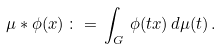<formula> <loc_0><loc_0><loc_500><loc_500>\mu * \phi ( x ) \, \colon = \, \int _ { G } \, \phi ( t x ) \, d \mu ( t ) \, .</formula> 